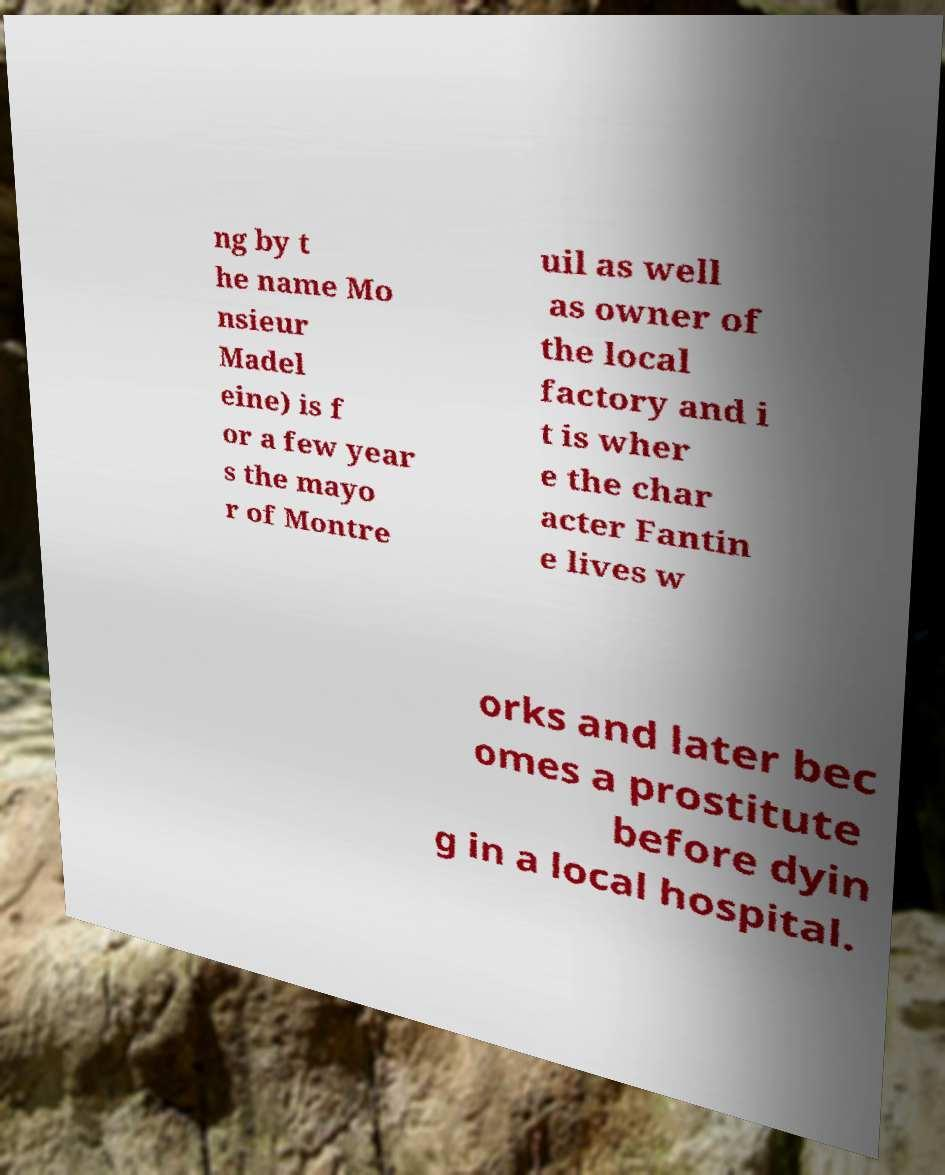Please identify and transcribe the text found in this image. ng by t he name Mo nsieur Madel eine) is f or a few year s the mayo r of Montre uil as well as owner of the local factory and i t is wher e the char acter Fantin e lives w orks and later bec omes a prostitute before dyin g in a local hospital. 